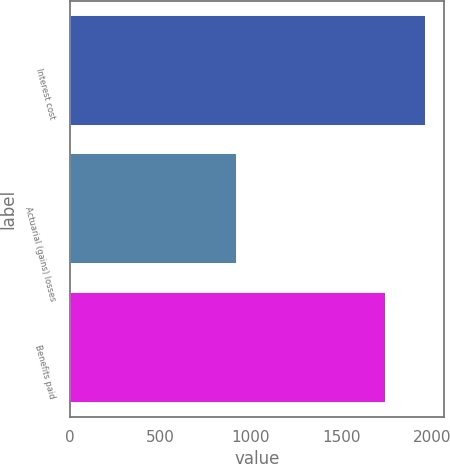Convert chart. <chart><loc_0><loc_0><loc_500><loc_500><bar_chart><fcel>Interest cost<fcel>Actuarial (gains) losses<fcel>Benefits paid<nl><fcel>1966<fcel>925<fcel>1743<nl></chart> 